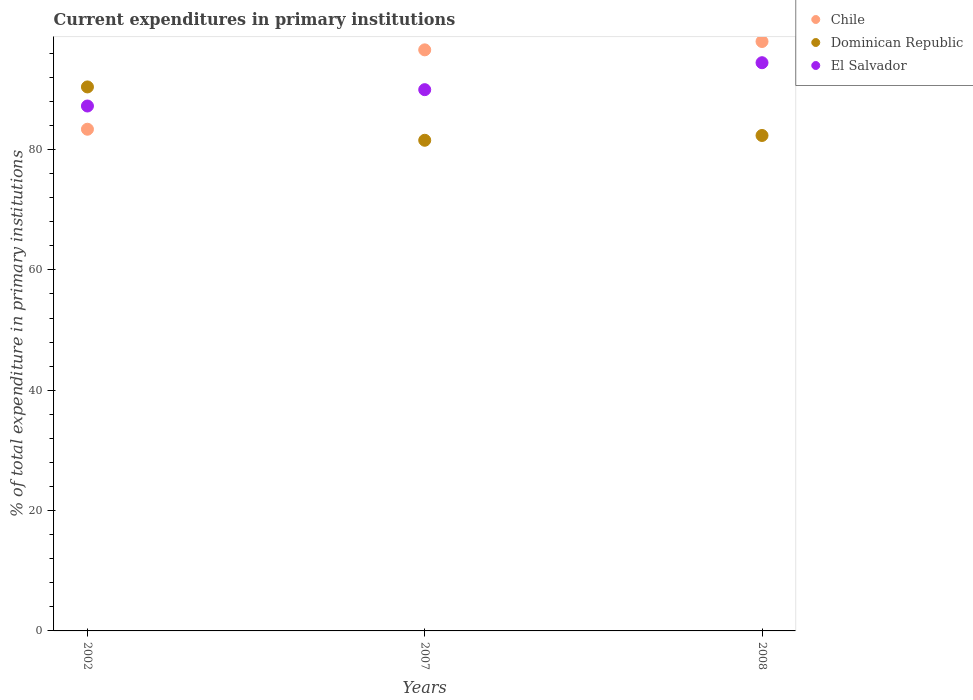How many different coloured dotlines are there?
Offer a terse response. 3. What is the current expenditures in primary institutions in El Salvador in 2002?
Offer a terse response. 87.23. Across all years, what is the maximum current expenditures in primary institutions in Dominican Republic?
Provide a succinct answer. 90.4. Across all years, what is the minimum current expenditures in primary institutions in Dominican Republic?
Provide a short and direct response. 81.54. What is the total current expenditures in primary institutions in Dominican Republic in the graph?
Ensure brevity in your answer.  254.27. What is the difference between the current expenditures in primary institutions in Dominican Republic in 2002 and that in 2007?
Your answer should be very brief. 8.86. What is the difference between the current expenditures in primary institutions in El Salvador in 2002 and the current expenditures in primary institutions in Dominican Republic in 2007?
Provide a short and direct response. 5.69. What is the average current expenditures in primary institutions in Chile per year?
Provide a short and direct response. 92.63. In the year 2008, what is the difference between the current expenditures in primary institutions in Chile and current expenditures in primary institutions in Dominican Republic?
Ensure brevity in your answer.  15.62. In how many years, is the current expenditures in primary institutions in Chile greater than 28 %?
Make the answer very short. 3. What is the ratio of the current expenditures in primary institutions in Dominican Republic in 2007 to that in 2008?
Offer a terse response. 0.99. What is the difference between the highest and the second highest current expenditures in primary institutions in El Salvador?
Keep it short and to the point. 4.48. What is the difference between the highest and the lowest current expenditures in primary institutions in Dominican Republic?
Keep it short and to the point. 8.86. In how many years, is the current expenditures in primary institutions in El Salvador greater than the average current expenditures in primary institutions in El Salvador taken over all years?
Your response must be concise. 1. How many years are there in the graph?
Your answer should be compact. 3. Does the graph contain any zero values?
Ensure brevity in your answer.  No. What is the title of the graph?
Provide a succinct answer. Current expenditures in primary institutions. Does "Montenegro" appear as one of the legend labels in the graph?
Offer a terse response. No. What is the label or title of the X-axis?
Your answer should be very brief. Years. What is the label or title of the Y-axis?
Provide a short and direct response. % of total expenditure in primary institutions. What is the % of total expenditure in primary institutions of Chile in 2002?
Provide a short and direct response. 83.37. What is the % of total expenditure in primary institutions of Dominican Republic in 2002?
Your response must be concise. 90.4. What is the % of total expenditure in primary institutions of El Salvador in 2002?
Provide a succinct answer. 87.23. What is the % of total expenditure in primary institutions in Chile in 2007?
Provide a short and direct response. 96.56. What is the % of total expenditure in primary institutions of Dominican Republic in 2007?
Your response must be concise. 81.54. What is the % of total expenditure in primary institutions of El Salvador in 2007?
Provide a short and direct response. 89.95. What is the % of total expenditure in primary institutions in Chile in 2008?
Provide a succinct answer. 97.95. What is the % of total expenditure in primary institutions of Dominican Republic in 2008?
Provide a succinct answer. 82.33. What is the % of total expenditure in primary institutions of El Salvador in 2008?
Ensure brevity in your answer.  94.42. Across all years, what is the maximum % of total expenditure in primary institutions of Chile?
Your answer should be compact. 97.95. Across all years, what is the maximum % of total expenditure in primary institutions of Dominican Republic?
Give a very brief answer. 90.4. Across all years, what is the maximum % of total expenditure in primary institutions of El Salvador?
Offer a very short reply. 94.42. Across all years, what is the minimum % of total expenditure in primary institutions in Chile?
Make the answer very short. 83.37. Across all years, what is the minimum % of total expenditure in primary institutions in Dominican Republic?
Ensure brevity in your answer.  81.54. Across all years, what is the minimum % of total expenditure in primary institutions of El Salvador?
Keep it short and to the point. 87.23. What is the total % of total expenditure in primary institutions in Chile in the graph?
Offer a very short reply. 277.88. What is the total % of total expenditure in primary institutions in Dominican Republic in the graph?
Keep it short and to the point. 254.27. What is the total % of total expenditure in primary institutions in El Salvador in the graph?
Your response must be concise. 271.6. What is the difference between the % of total expenditure in primary institutions in Chile in 2002 and that in 2007?
Your answer should be compact. -13.19. What is the difference between the % of total expenditure in primary institutions of Dominican Republic in 2002 and that in 2007?
Offer a terse response. 8.86. What is the difference between the % of total expenditure in primary institutions of El Salvador in 2002 and that in 2007?
Your response must be concise. -2.72. What is the difference between the % of total expenditure in primary institutions of Chile in 2002 and that in 2008?
Your answer should be very brief. -14.58. What is the difference between the % of total expenditure in primary institutions of Dominican Republic in 2002 and that in 2008?
Make the answer very short. 8.07. What is the difference between the % of total expenditure in primary institutions of El Salvador in 2002 and that in 2008?
Give a very brief answer. -7.19. What is the difference between the % of total expenditure in primary institutions of Chile in 2007 and that in 2008?
Your answer should be compact. -1.39. What is the difference between the % of total expenditure in primary institutions in Dominican Republic in 2007 and that in 2008?
Give a very brief answer. -0.8. What is the difference between the % of total expenditure in primary institutions in El Salvador in 2007 and that in 2008?
Keep it short and to the point. -4.48. What is the difference between the % of total expenditure in primary institutions of Chile in 2002 and the % of total expenditure in primary institutions of Dominican Republic in 2007?
Provide a short and direct response. 1.83. What is the difference between the % of total expenditure in primary institutions of Chile in 2002 and the % of total expenditure in primary institutions of El Salvador in 2007?
Provide a short and direct response. -6.58. What is the difference between the % of total expenditure in primary institutions of Dominican Republic in 2002 and the % of total expenditure in primary institutions of El Salvador in 2007?
Offer a terse response. 0.45. What is the difference between the % of total expenditure in primary institutions of Chile in 2002 and the % of total expenditure in primary institutions of Dominican Republic in 2008?
Give a very brief answer. 1.04. What is the difference between the % of total expenditure in primary institutions in Chile in 2002 and the % of total expenditure in primary institutions in El Salvador in 2008?
Your answer should be compact. -11.05. What is the difference between the % of total expenditure in primary institutions in Dominican Republic in 2002 and the % of total expenditure in primary institutions in El Salvador in 2008?
Ensure brevity in your answer.  -4.02. What is the difference between the % of total expenditure in primary institutions in Chile in 2007 and the % of total expenditure in primary institutions in Dominican Republic in 2008?
Offer a very short reply. 14.23. What is the difference between the % of total expenditure in primary institutions in Chile in 2007 and the % of total expenditure in primary institutions in El Salvador in 2008?
Your answer should be very brief. 2.14. What is the difference between the % of total expenditure in primary institutions of Dominican Republic in 2007 and the % of total expenditure in primary institutions of El Salvador in 2008?
Your answer should be very brief. -12.89. What is the average % of total expenditure in primary institutions of Chile per year?
Keep it short and to the point. 92.63. What is the average % of total expenditure in primary institutions in Dominican Republic per year?
Offer a terse response. 84.76. What is the average % of total expenditure in primary institutions of El Salvador per year?
Offer a very short reply. 90.53. In the year 2002, what is the difference between the % of total expenditure in primary institutions of Chile and % of total expenditure in primary institutions of Dominican Republic?
Make the answer very short. -7.03. In the year 2002, what is the difference between the % of total expenditure in primary institutions of Chile and % of total expenditure in primary institutions of El Salvador?
Provide a succinct answer. -3.86. In the year 2002, what is the difference between the % of total expenditure in primary institutions of Dominican Republic and % of total expenditure in primary institutions of El Salvador?
Your answer should be compact. 3.17. In the year 2007, what is the difference between the % of total expenditure in primary institutions in Chile and % of total expenditure in primary institutions in Dominican Republic?
Make the answer very short. 15.02. In the year 2007, what is the difference between the % of total expenditure in primary institutions of Chile and % of total expenditure in primary institutions of El Salvador?
Your answer should be very brief. 6.62. In the year 2007, what is the difference between the % of total expenditure in primary institutions of Dominican Republic and % of total expenditure in primary institutions of El Salvador?
Your answer should be compact. -8.41. In the year 2008, what is the difference between the % of total expenditure in primary institutions in Chile and % of total expenditure in primary institutions in Dominican Republic?
Provide a short and direct response. 15.62. In the year 2008, what is the difference between the % of total expenditure in primary institutions of Chile and % of total expenditure in primary institutions of El Salvador?
Offer a very short reply. 3.52. In the year 2008, what is the difference between the % of total expenditure in primary institutions in Dominican Republic and % of total expenditure in primary institutions in El Salvador?
Provide a short and direct response. -12.09. What is the ratio of the % of total expenditure in primary institutions in Chile in 2002 to that in 2007?
Your response must be concise. 0.86. What is the ratio of the % of total expenditure in primary institutions in Dominican Republic in 2002 to that in 2007?
Provide a short and direct response. 1.11. What is the ratio of the % of total expenditure in primary institutions of El Salvador in 2002 to that in 2007?
Ensure brevity in your answer.  0.97. What is the ratio of the % of total expenditure in primary institutions of Chile in 2002 to that in 2008?
Offer a terse response. 0.85. What is the ratio of the % of total expenditure in primary institutions of Dominican Republic in 2002 to that in 2008?
Offer a terse response. 1.1. What is the ratio of the % of total expenditure in primary institutions of El Salvador in 2002 to that in 2008?
Your response must be concise. 0.92. What is the ratio of the % of total expenditure in primary institutions of Chile in 2007 to that in 2008?
Your answer should be very brief. 0.99. What is the ratio of the % of total expenditure in primary institutions of Dominican Republic in 2007 to that in 2008?
Your answer should be very brief. 0.99. What is the ratio of the % of total expenditure in primary institutions in El Salvador in 2007 to that in 2008?
Offer a very short reply. 0.95. What is the difference between the highest and the second highest % of total expenditure in primary institutions of Chile?
Your answer should be very brief. 1.39. What is the difference between the highest and the second highest % of total expenditure in primary institutions of Dominican Republic?
Provide a succinct answer. 8.07. What is the difference between the highest and the second highest % of total expenditure in primary institutions in El Salvador?
Provide a succinct answer. 4.48. What is the difference between the highest and the lowest % of total expenditure in primary institutions in Chile?
Make the answer very short. 14.58. What is the difference between the highest and the lowest % of total expenditure in primary institutions in Dominican Republic?
Make the answer very short. 8.86. What is the difference between the highest and the lowest % of total expenditure in primary institutions in El Salvador?
Offer a very short reply. 7.19. 